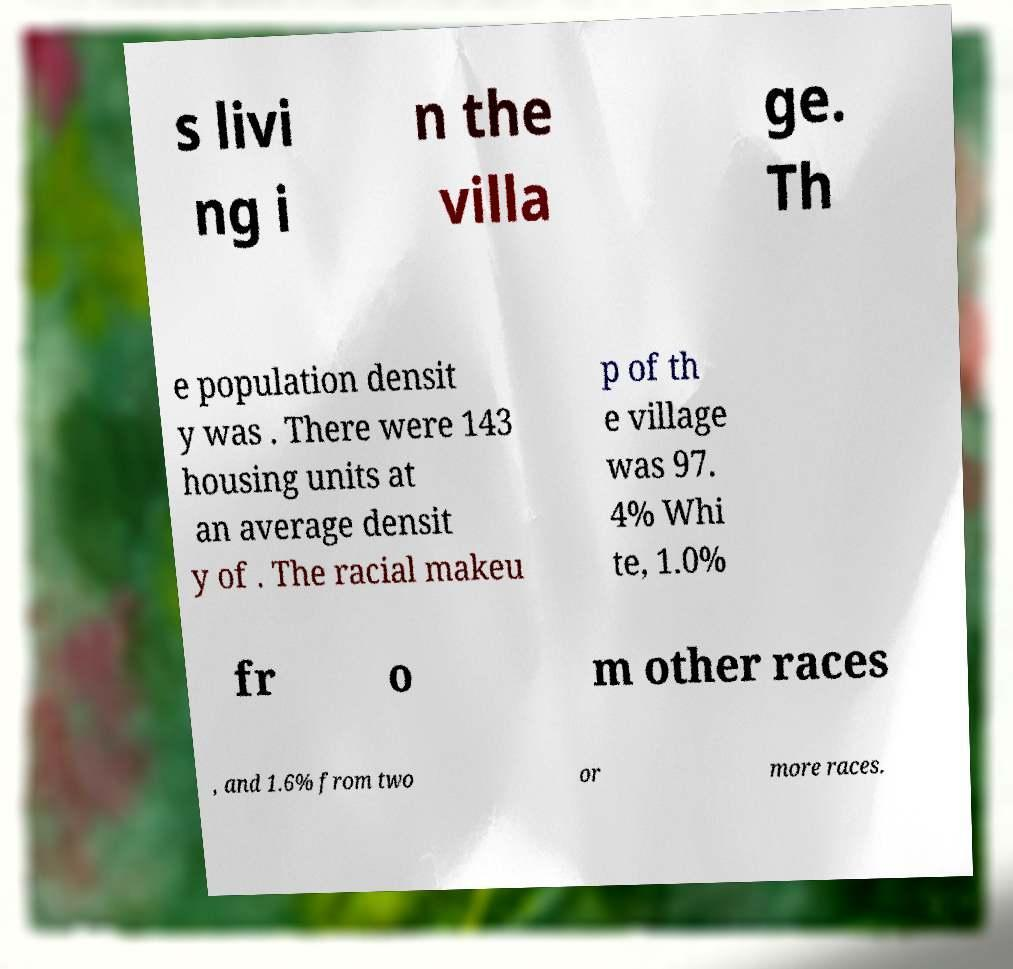Can you accurately transcribe the text from the provided image for me? s livi ng i n the villa ge. Th e population densit y was . There were 143 housing units at an average densit y of . The racial makeu p of th e village was 97. 4% Whi te, 1.0% fr o m other races , and 1.6% from two or more races. 